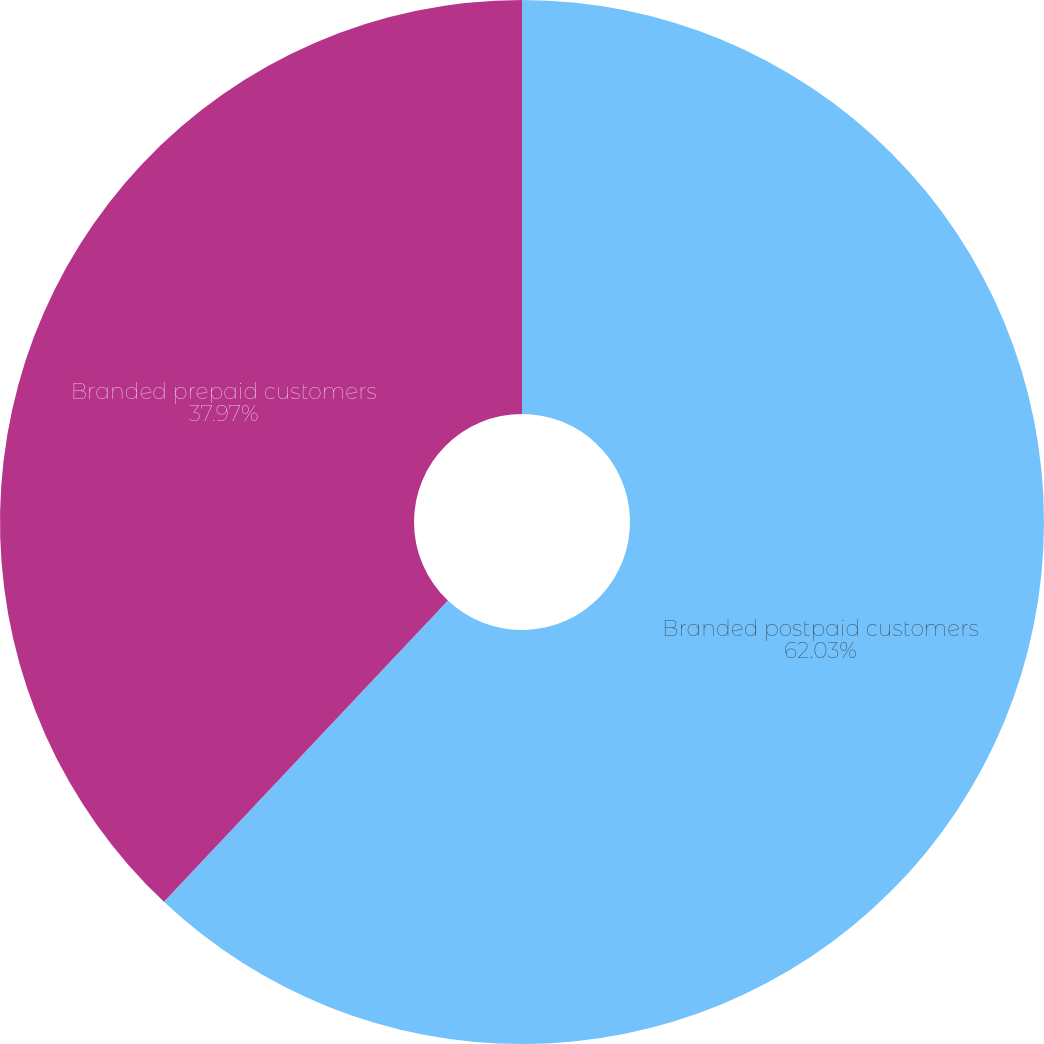Convert chart to OTSL. <chart><loc_0><loc_0><loc_500><loc_500><pie_chart><fcel>Branded postpaid customers<fcel>Branded prepaid customers<nl><fcel>62.03%<fcel>37.97%<nl></chart> 